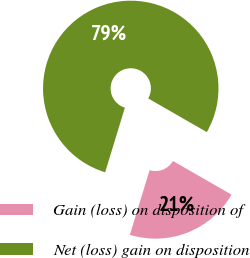Convert chart to OTSL. <chart><loc_0><loc_0><loc_500><loc_500><pie_chart><fcel>Gain (loss) on disposition of<fcel>Net (loss) gain on disposition<nl><fcel>21.41%<fcel>78.59%<nl></chart> 